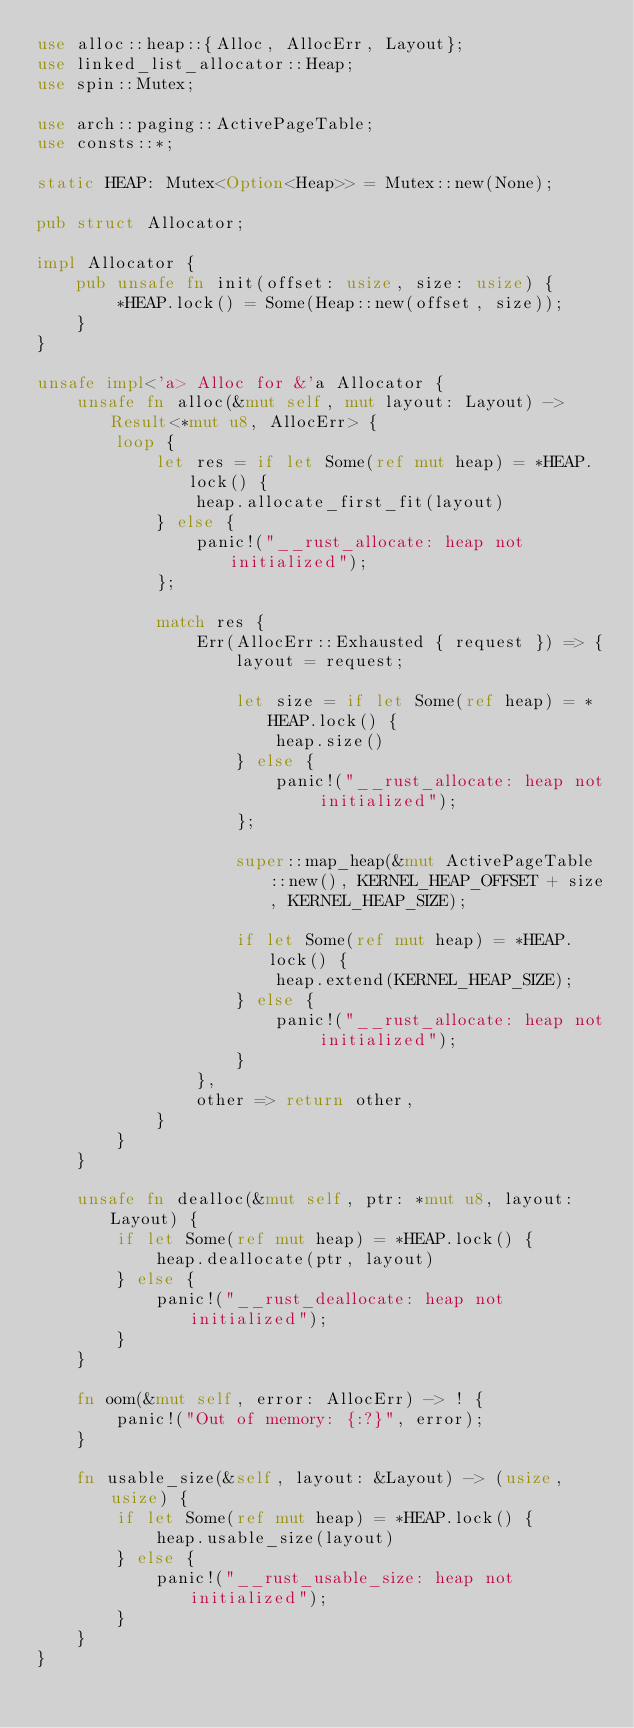<code> <loc_0><loc_0><loc_500><loc_500><_Rust_>use alloc::heap::{Alloc, AllocErr, Layout};
use linked_list_allocator::Heap;
use spin::Mutex;

use arch::paging::ActivePageTable;
use consts::*;

static HEAP: Mutex<Option<Heap>> = Mutex::new(None);

pub struct Allocator;

impl Allocator {
    pub unsafe fn init(offset: usize, size: usize) {
        *HEAP.lock() = Some(Heap::new(offset, size));
    }
}

unsafe impl<'a> Alloc for &'a Allocator {
    unsafe fn alloc(&mut self, mut layout: Layout) -> Result<*mut u8, AllocErr> {
        loop {
            let res = if let Some(ref mut heap) = *HEAP.lock() {
                heap.allocate_first_fit(layout)
            } else {
                panic!("__rust_allocate: heap not initialized");
            };

            match res {
                Err(AllocErr::Exhausted { request }) => {
                    layout = request;

                    let size = if let Some(ref heap) = *HEAP.lock() {
                        heap.size()
                    } else {
                        panic!("__rust_allocate: heap not initialized");
                    };

                    super::map_heap(&mut ActivePageTable::new(), KERNEL_HEAP_OFFSET + size, KERNEL_HEAP_SIZE);

                    if let Some(ref mut heap) = *HEAP.lock() {
                        heap.extend(KERNEL_HEAP_SIZE);
                    } else {
                        panic!("__rust_allocate: heap not initialized");
                    }
                },
                other => return other,
            }
        }
    }

    unsafe fn dealloc(&mut self, ptr: *mut u8, layout: Layout) {
        if let Some(ref mut heap) = *HEAP.lock() {
            heap.deallocate(ptr, layout)
        } else {
            panic!("__rust_deallocate: heap not initialized");
        }
    }

    fn oom(&mut self, error: AllocErr) -> ! {
        panic!("Out of memory: {:?}", error);
    }

    fn usable_size(&self, layout: &Layout) -> (usize, usize) {
        if let Some(ref mut heap) = *HEAP.lock() {
            heap.usable_size(layout)
        } else {
            panic!("__rust_usable_size: heap not initialized");
        }
    }
}
</code> 